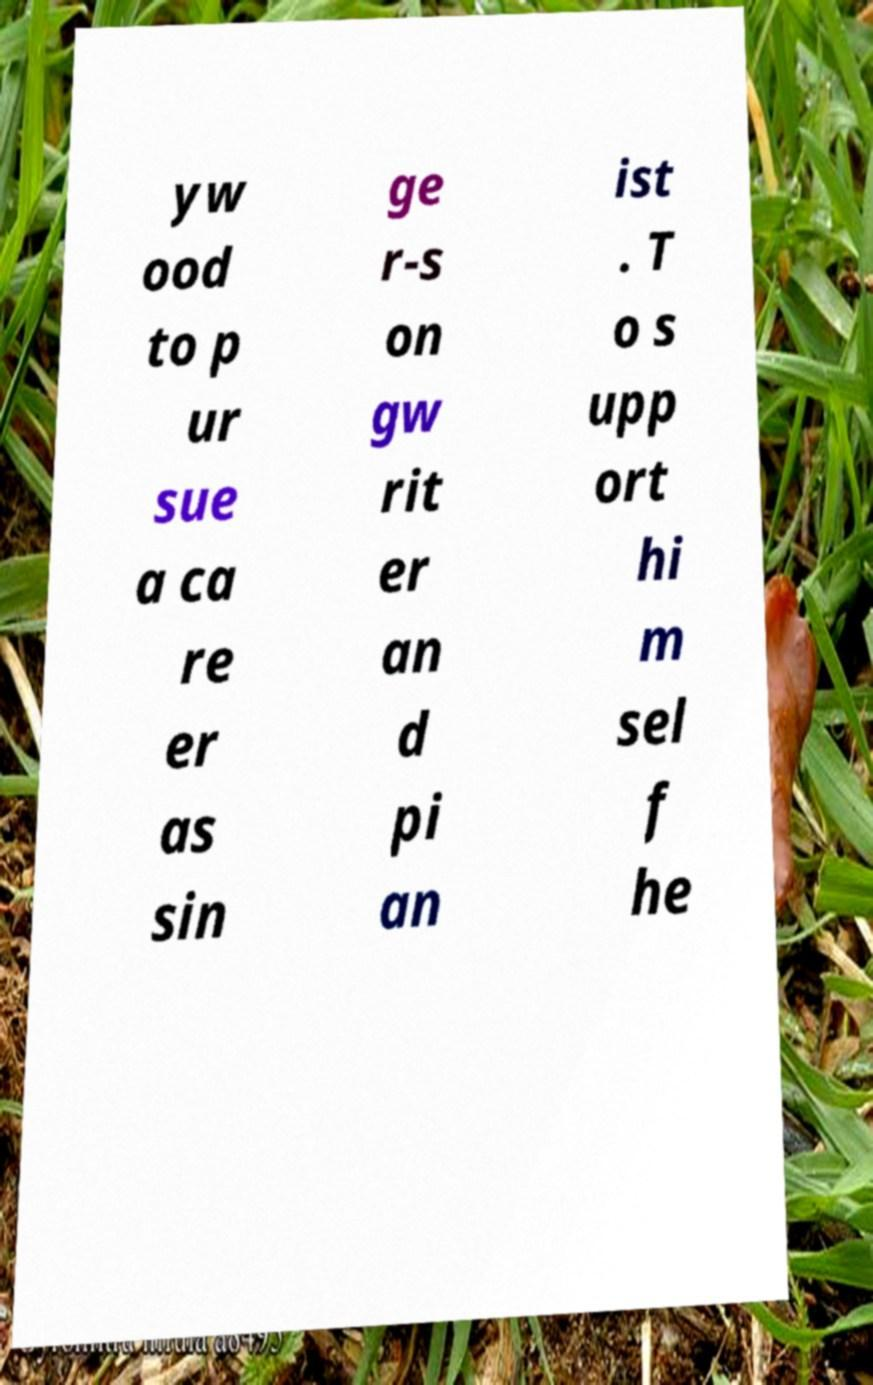Please read and relay the text visible in this image. What does it say? yw ood to p ur sue a ca re er as sin ge r-s on gw rit er an d pi an ist . T o s upp ort hi m sel f he 